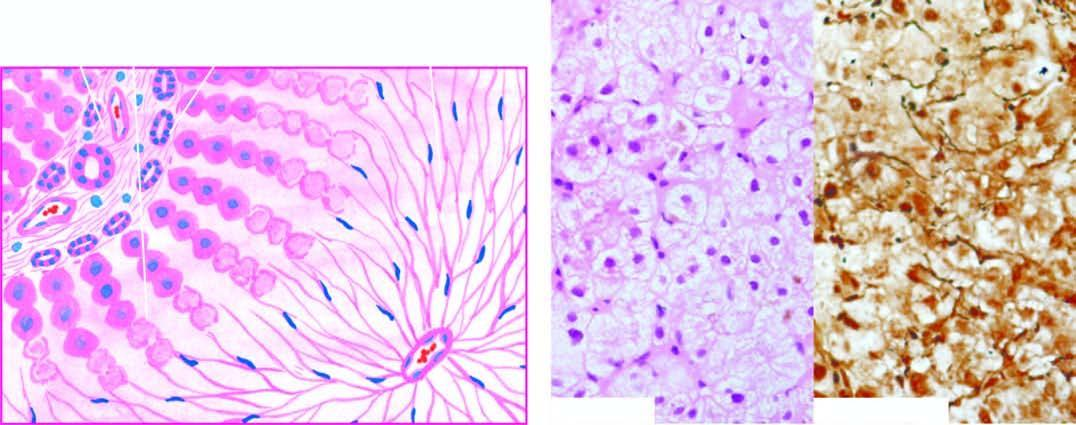what is there with only collapsed reticulin framework left out in their place, high lighted by reticulin stain right photomicrograph?
Answer the question using a single word or phrase. Wiping out of liver lobules 